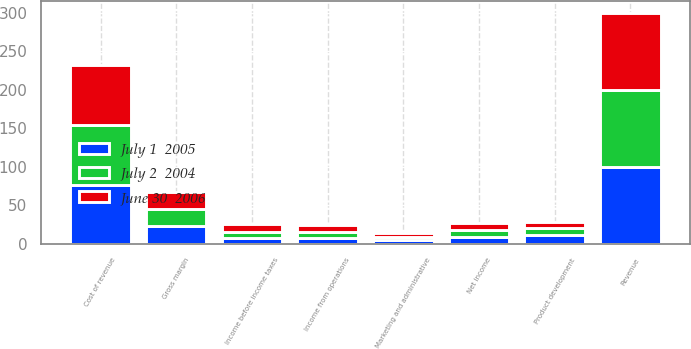<chart> <loc_0><loc_0><loc_500><loc_500><stacked_bar_chart><ecel><fcel>Revenue<fcel>Cost of revenue<fcel>Gross margin<fcel>Product development<fcel>Marketing and administrative<fcel>Income from operations<fcel>Income before income taxes<fcel>Net income<nl><fcel>June 30  2006<fcel>100<fcel>77<fcel>23<fcel>9<fcel>5<fcel>9<fcel>10<fcel>9<nl><fcel>July 2  2004<fcel>100<fcel>78<fcel>22<fcel>9<fcel>4<fcel>9<fcel>9<fcel>9<nl><fcel>July 1  2005<fcel>100<fcel>77<fcel>23<fcel>11<fcel>5<fcel>7<fcel>7<fcel>9<nl></chart> 